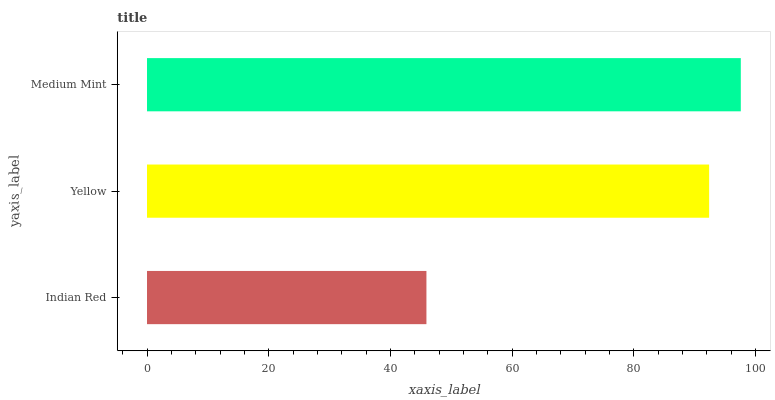Is Indian Red the minimum?
Answer yes or no. Yes. Is Medium Mint the maximum?
Answer yes or no. Yes. Is Yellow the minimum?
Answer yes or no. No. Is Yellow the maximum?
Answer yes or no. No. Is Yellow greater than Indian Red?
Answer yes or no. Yes. Is Indian Red less than Yellow?
Answer yes or no. Yes. Is Indian Red greater than Yellow?
Answer yes or no. No. Is Yellow less than Indian Red?
Answer yes or no. No. Is Yellow the high median?
Answer yes or no. Yes. Is Yellow the low median?
Answer yes or no. Yes. Is Indian Red the high median?
Answer yes or no. No. Is Medium Mint the low median?
Answer yes or no. No. 